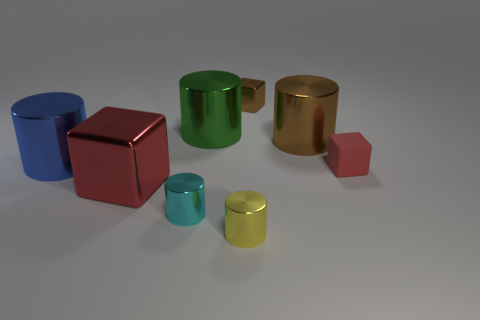Does the small matte cube have the same color as the big cube?
Ensure brevity in your answer.  Yes. There is a green object that is the same shape as the big blue shiny object; what is its material?
Provide a succinct answer. Metal. Is the color of the small shiny thing that is behind the green metallic cylinder the same as the shiny cylinder that is on the right side of the yellow metal cylinder?
Keep it short and to the point. Yes. There is a brown metallic object behind the green metallic cylinder; what is its shape?
Offer a terse response. Cube. The large cube is what color?
Offer a very short reply. Red. There is a small brown thing that is made of the same material as the cyan thing; what is its shape?
Keep it short and to the point. Cube. There is a cylinder that is right of the yellow shiny thing; is it the same size as the yellow cylinder?
Offer a very short reply. No. What number of things are big green things behind the cyan shiny thing or large things in front of the green metal object?
Make the answer very short. 4. Is the color of the big metal cylinder that is on the right side of the yellow cylinder the same as the small metal block?
Ensure brevity in your answer.  Yes. How many metallic objects are either small cyan objects or big blue objects?
Ensure brevity in your answer.  2. 